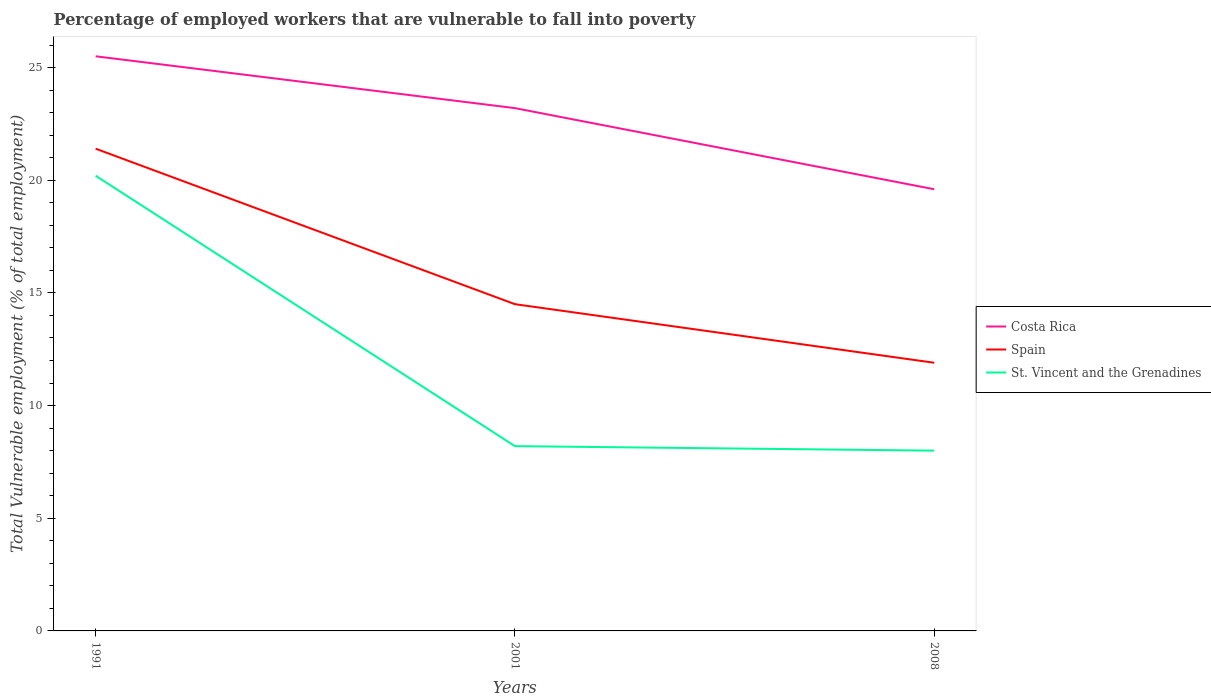Does the line corresponding to Costa Rica intersect with the line corresponding to St. Vincent and the Grenadines?
Your answer should be compact. No. Across all years, what is the maximum percentage of employed workers who are vulnerable to fall into poverty in Costa Rica?
Your answer should be compact. 19.6. In which year was the percentage of employed workers who are vulnerable to fall into poverty in St. Vincent and the Grenadines maximum?
Provide a succinct answer. 2008. What is the total percentage of employed workers who are vulnerable to fall into poverty in Costa Rica in the graph?
Provide a succinct answer. 3.6. What is the difference between the highest and the second highest percentage of employed workers who are vulnerable to fall into poverty in Costa Rica?
Ensure brevity in your answer.  5.9. What is the difference between the highest and the lowest percentage of employed workers who are vulnerable to fall into poverty in St. Vincent and the Grenadines?
Make the answer very short. 1. What is the difference between two consecutive major ticks on the Y-axis?
Provide a succinct answer. 5. Are the values on the major ticks of Y-axis written in scientific E-notation?
Make the answer very short. No. Where does the legend appear in the graph?
Provide a succinct answer. Center right. How are the legend labels stacked?
Offer a terse response. Vertical. What is the title of the graph?
Offer a terse response. Percentage of employed workers that are vulnerable to fall into poverty. What is the label or title of the X-axis?
Offer a very short reply. Years. What is the label or title of the Y-axis?
Offer a terse response. Total Vulnerable employment (% of total employment). What is the Total Vulnerable employment (% of total employment) in Spain in 1991?
Keep it short and to the point. 21.4. What is the Total Vulnerable employment (% of total employment) of St. Vincent and the Grenadines in 1991?
Give a very brief answer. 20.2. What is the Total Vulnerable employment (% of total employment) in Costa Rica in 2001?
Provide a short and direct response. 23.2. What is the Total Vulnerable employment (% of total employment) in Spain in 2001?
Offer a very short reply. 14.5. What is the Total Vulnerable employment (% of total employment) of St. Vincent and the Grenadines in 2001?
Offer a very short reply. 8.2. What is the Total Vulnerable employment (% of total employment) of Costa Rica in 2008?
Provide a succinct answer. 19.6. What is the Total Vulnerable employment (% of total employment) of Spain in 2008?
Keep it short and to the point. 11.9. What is the Total Vulnerable employment (% of total employment) in St. Vincent and the Grenadines in 2008?
Provide a succinct answer. 8. Across all years, what is the maximum Total Vulnerable employment (% of total employment) in Spain?
Your answer should be compact. 21.4. Across all years, what is the maximum Total Vulnerable employment (% of total employment) in St. Vincent and the Grenadines?
Your response must be concise. 20.2. Across all years, what is the minimum Total Vulnerable employment (% of total employment) in Costa Rica?
Your answer should be compact. 19.6. Across all years, what is the minimum Total Vulnerable employment (% of total employment) in Spain?
Keep it short and to the point. 11.9. Across all years, what is the minimum Total Vulnerable employment (% of total employment) of St. Vincent and the Grenadines?
Your response must be concise. 8. What is the total Total Vulnerable employment (% of total employment) in Costa Rica in the graph?
Your answer should be very brief. 68.3. What is the total Total Vulnerable employment (% of total employment) in Spain in the graph?
Your answer should be very brief. 47.8. What is the total Total Vulnerable employment (% of total employment) in St. Vincent and the Grenadines in the graph?
Your response must be concise. 36.4. What is the difference between the Total Vulnerable employment (% of total employment) of Costa Rica in 1991 and that in 2001?
Offer a very short reply. 2.3. What is the difference between the Total Vulnerable employment (% of total employment) of St. Vincent and the Grenadines in 1991 and that in 2001?
Ensure brevity in your answer.  12. What is the difference between the Total Vulnerable employment (% of total employment) of St. Vincent and the Grenadines in 1991 and that in 2008?
Offer a very short reply. 12.2. What is the difference between the Total Vulnerable employment (% of total employment) of Spain in 2001 and that in 2008?
Offer a terse response. 2.6. What is the difference between the Total Vulnerable employment (% of total employment) in Spain in 1991 and the Total Vulnerable employment (% of total employment) in St. Vincent and the Grenadines in 2001?
Offer a terse response. 13.2. What is the difference between the Total Vulnerable employment (% of total employment) of Costa Rica in 1991 and the Total Vulnerable employment (% of total employment) of St. Vincent and the Grenadines in 2008?
Give a very brief answer. 17.5. What is the difference between the Total Vulnerable employment (% of total employment) of Spain in 1991 and the Total Vulnerable employment (% of total employment) of St. Vincent and the Grenadines in 2008?
Offer a terse response. 13.4. What is the average Total Vulnerable employment (% of total employment) of Costa Rica per year?
Your answer should be very brief. 22.77. What is the average Total Vulnerable employment (% of total employment) in Spain per year?
Provide a short and direct response. 15.93. What is the average Total Vulnerable employment (% of total employment) of St. Vincent and the Grenadines per year?
Make the answer very short. 12.13. In the year 1991, what is the difference between the Total Vulnerable employment (% of total employment) in Costa Rica and Total Vulnerable employment (% of total employment) in Spain?
Offer a terse response. 4.1. In the year 1991, what is the difference between the Total Vulnerable employment (% of total employment) of Costa Rica and Total Vulnerable employment (% of total employment) of St. Vincent and the Grenadines?
Offer a terse response. 5.3. In the year 1991, what is the difference between the Total Vulnerable employment (% of total employment) of Spain and Total Vulnerable employment (% of total employment) of St. Vincent and the Grenadines?
Make the answer very short. 1.2. In the year 2001, what is the difference between the Total Vulnerable employment (% of total employment) of Costa Rica and Total Vulnerable employment (% of total employment) of Spain?
Your response must be concise. 8.7. In the year 2001, what is the difference between the Total Vulnerable employment (% of total employment) in Costa Rica and Total Vulnerable employment (% of total employment) in St. Vincent and the Grenadines?
Your answer should be very brief. 15. In the year 2008, what is the difference between the Total Vulnerable employment (% of total employment) in Costa Rica and Total Vulnerable employment (% of total employment) in St. Vincent and the Grenadines?
Offer a very short reply. 11.6. In the year 2008, what is the difference between the Total Vulnerable employment (% of total employment) of Spain and Total Vulnerable employment (% of total employment) of St. Vincent and the Grenadines?
Give a very brief answer. 3.9. What is the ratio of the Total Vulnerable employment (% of total employment) of Costa Rica in 1991 to that in 2001?
Give a very brief answer. 1.1. What is the ratio of the Total Vulnerable employment (% of total employment) of Spain in 1991 to that in 2001?
Provide a short and direct response. 1.48. What is the ratio of the Total Vulnerable employment (% of total employment) of St. Vincent and the Grenadines in 1991 to that in 2001?
Give a very brief answer. 2.46. What is the ratio of the Total Vulnerable employment (% of total employment) in Costa Rica in 1991 to that in 2008?
Provide a short and direct response. 1.3. What is the ratio of the Total Vulnerable employment (% of total employment) of Spain in 1991 to that in 2008?
Provide a succinct answer. 1.8. What is the ratio of the Total Vulnerable employment (% of total employment) in St. Vincent and the Grenadines in 1991 to that in 2008?
Provide a succinct answer. 2.52. What is the ratio of the Total Vulnerable employment (% of total employment) in Costa Rica in 2001 to that in 2008?
Ensure brevity in your answer.  1.18. What is the ratio of the Total Vulnerable employment (% of total employment) of Spain in 2001 to that in 2008?
Offer a very short reply. 1.22. What is the difference between the highest and the second highest Total Vulnerable employment (% of total employment) in Costa Rica?
Your answer should be compact. 2.3. What is the difference between the highest and the lowest Total Vulnerable employment (% of total employment) in St. Vincent and the Grenadines?
Your response must be concise. 12.2. 